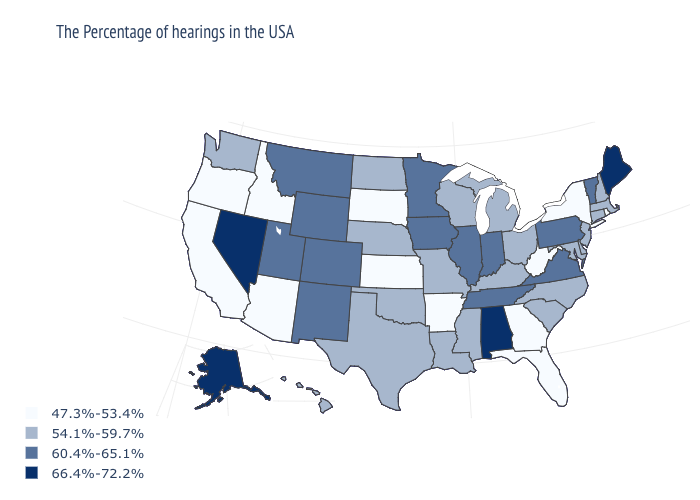What is the value of Rhode Island?
Quick response, please. 47.3%-53.4%. Is the legend a continuous bar?
Give a very brief answer. No. What is the highest value in states that border Colorado?
Be succinct. 60.4%-65.1%. How many symbols are there in the legend?
Concise answer only. 4. Does Pennsylvania have the lowest value in the Northeast?
Quick response, please. No. What is the value of Rhode Island?
Write a very short answer. 47.3%-53.4%. What is the highest value in the USA?
Write a very short answer. 66.4%-72.2%. What is the value of New York?
Concise answer only. 47.3%-53.4%. Does the map have missing data?
Write a very short answer. No. Name the states that have a value in the range 47.3%-53.4%?
Keep it brief. Rhode Island, New York, West Virginia, Florida, Georgia, Arkansas, Kansas, South Dakota, Arizona, Idaho, California, Oregon. Among the states that border Nebraska , does Kansas have the highest value?
Short answer required. No. What is the value of Montana?
Write a very short answer. 60.4%-65.1%. What is the value of Pennsylvania?
Write a very short answer. 60.4%-65.1%. Does the map have missing data?
Short answer required. No. Does Kansas have the lowest value in the USA?
Give a very brief answer. Yes. 